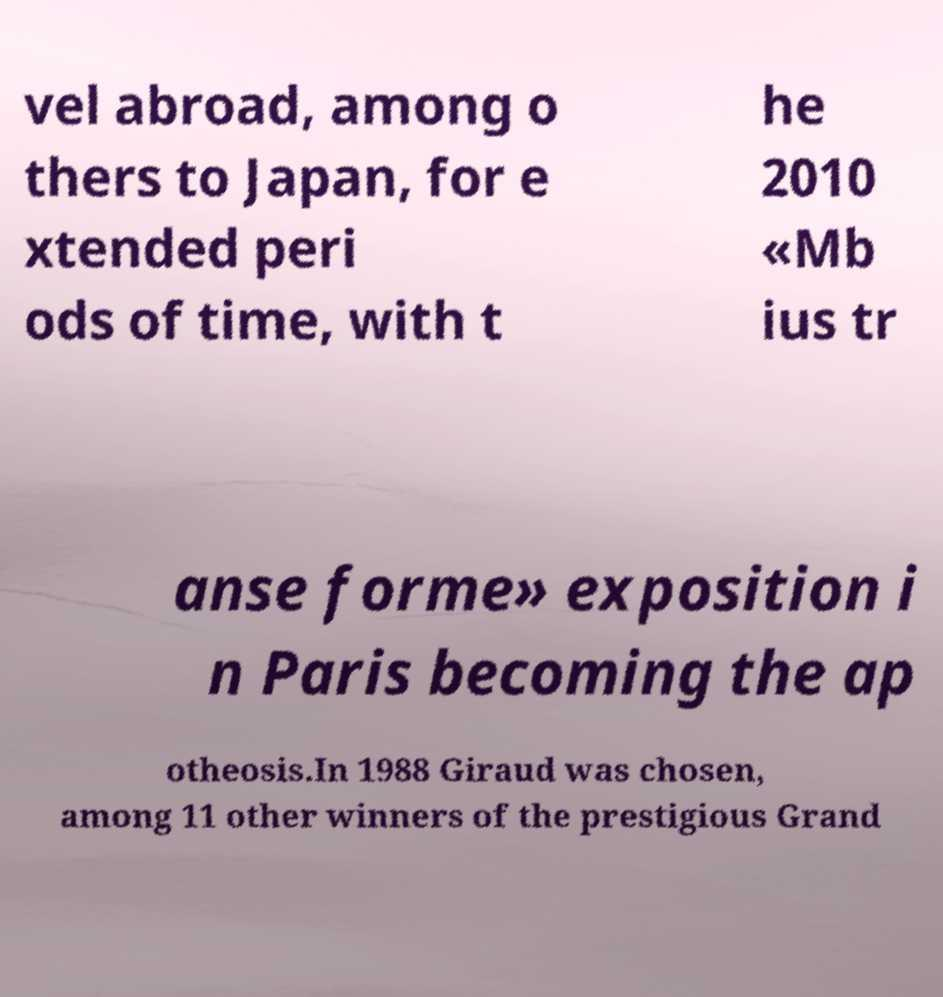Can you read and provide the text displayed in the image?This photo seems to have some interesting text. Can you extract and type it out for me? vel abroad, among o thers to Japan, for e xtended peri ods of time, with t he 2010 «Mb ius tr anse forme» exposition i n Paris becoming the ap otheosis.In 1988 Giraud was chosen, among 11 other winners of the prestigious Grand 